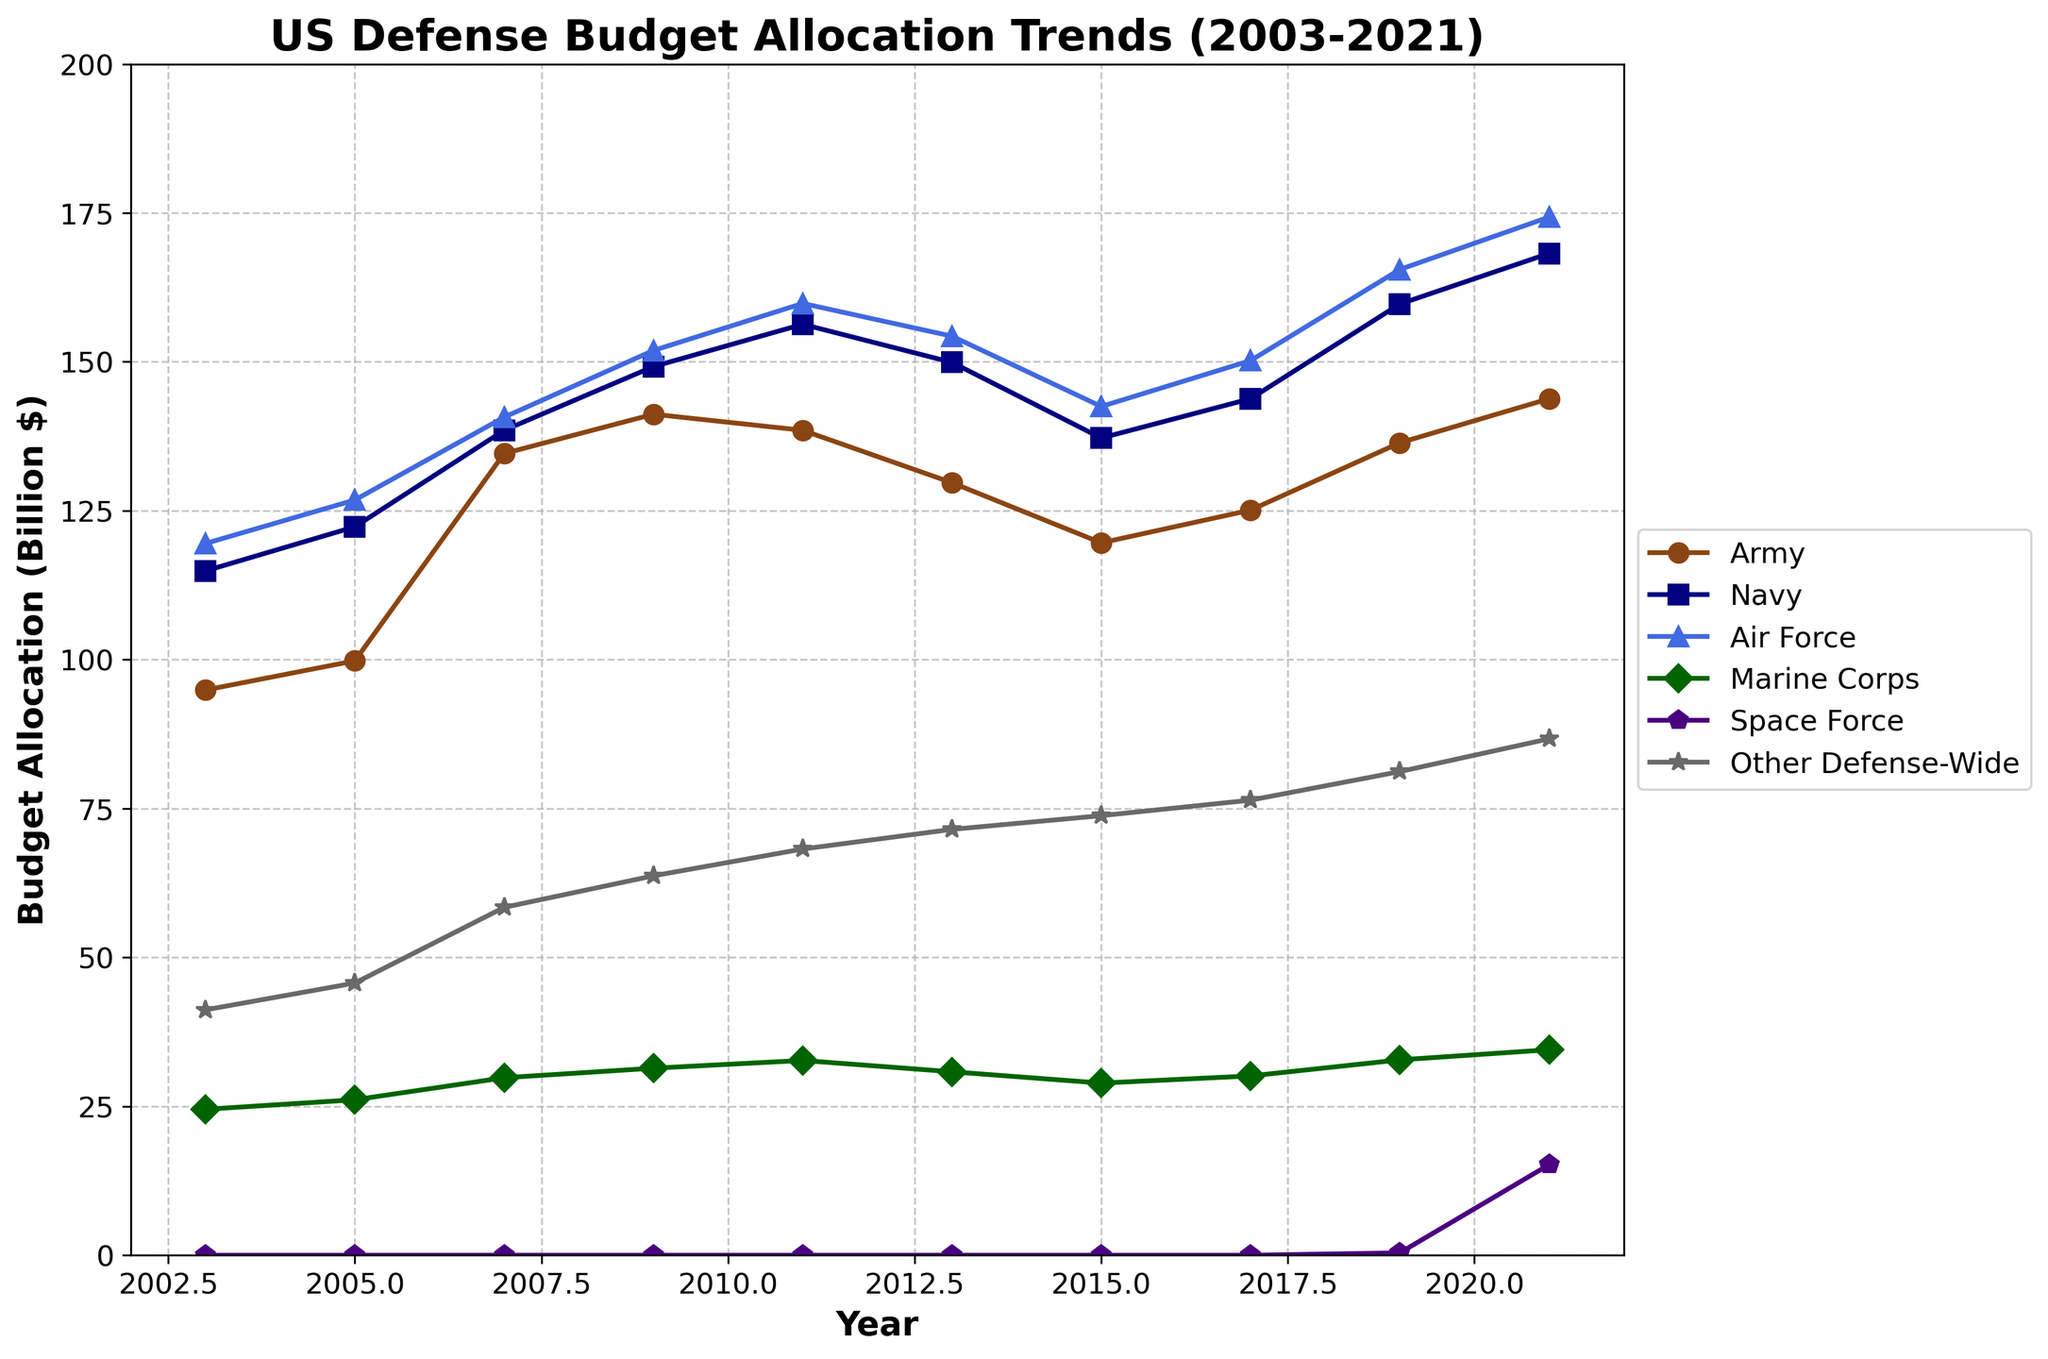What is the general trend in the budget allocation for the Army from 2003 to 2021? To determine the general trend, look at the budget allocations for the Army at the start (2003) and end (2021) points and observe their changes across the years. Starting at 94.9 billion in 2003, it reaches 143.8 billion in 2021, showing a general increasing trend.
Answer: Increasing Which military branch received the highest budget allocation in 2021? To find this, look at the budget allocations for all branches in the year 2021 and identify the highest value. The Air Force received the highest allocation at 174.3 billion.
Answer: Air Force How much did the Navy's budget allocation increase from 2003 to 2021? First, identify the Navy's budget in 2003 (114.9 billion) and in 2021 (168.2 billion), and then subtract the former from the latter to find the increase: 168.2 - 114.9 = 53.3 billion.
Answer: 53.3 billion Compare the budget allocations of the Marine Corps and the Space Force in their respective maximum years. Identify the maximum value for Marine Corps (34.5 billion in 2021) and for Space Force (15.2 billion in 2021), and then compare these two values. Marine Corps has a higher allocation than Space Force.
Answer: Marine Corps What was the average budget allocation for the Air Force over the 20 years? Sum the Air Force's budget allocations over all the years (119.5 + 126.8 + 140.7 + 151.9 + 159.8 + 154.3 + 142.5 + 150.2 + 165.5 + 174.3 = 1485.5) and then divide by the number of years (10) to find the average: 1485.5 / 10 = 148.55 billion.
Answer: 148.55 billion By how much did "Other Defense-Wide" budget allocation increase from 2003 to 2021? First, identify the "Other Defense-Wide" budget in 2003 (41.2 billion) and in 2021 (86.7 billion), and then subtract the former from the latter to find the increase: 86.7 - 41.2 = 45.5 billion.
Answer: 45.5 billion In which year did the Navy surpass the Air Force in budget allocation for the first time? Examine the budget allocations for both the Navy and the Air Force year by year to determine when the Navy's allocation exceeded the Air Force's for the first time. This happened in 2013 when the Navy had 149.9 billion and the Air Force had 154.3 billion.
Answer: 2013 By what percentage did the Marine Corps budget increase from 2003 to 2021? Calculate the percentage increase over the time period. First, find the difference between the end value and the starting value (34.5 - 24.5 = 10 billion), then divide by the starting value, and multiply by 100 to get the percentage: (10 / 24.5) * 100 ≈ 40.82%.
Answer: 40.82% How did the introduction of the Space Force in the budget allocations start in 2019 impact the “Other Defense-Wide” category's budget? Compare the increases in budgets for "Other Defense-Wide" before and after 2019, noting that the Space Force's budget appears explicitly from 2019 onwards. The budget for “Other Defense-Wide” slightly increased between 2019 (81.2 billion) and 2021 (86.7 billion), indicating a reallocation as Space Force got 0.4 billion in 2019 and increased to 15.2 billion by 2021.
Answer: Minor reallocation to Space Force Between which two consecutive years did the Army see the highest increase in budget allocation? Identify the year-over-year differences in the Army's budget and find the maximum increase: 
2005-2003: 99.8 - 94.9 = 4.9 billion  
2007-2005: 134.6 - 99.8 = 34.8 billion  
2009-2007: 141.2 - 134.6 = 6.6 billion  
2011-2009: 138.5 - 141.2 = -2.7 billion  
2013-2011: 129.7 - 138.5 = -8.8 billion  
2015-2013: 119.6 - 129.7 = -10.1 billion  
2017-2015: 125.1 - 119.6 = 5.5 billion  
2019-2017: 136.4 - 125.1 = 11.3 billion  
2021-2019: 143.8 - 136.4 = 7.4 billion  
The highest increase happened between 2005 and 2007 with an increase of 34.8 billion.
Answer: 2005-2007 